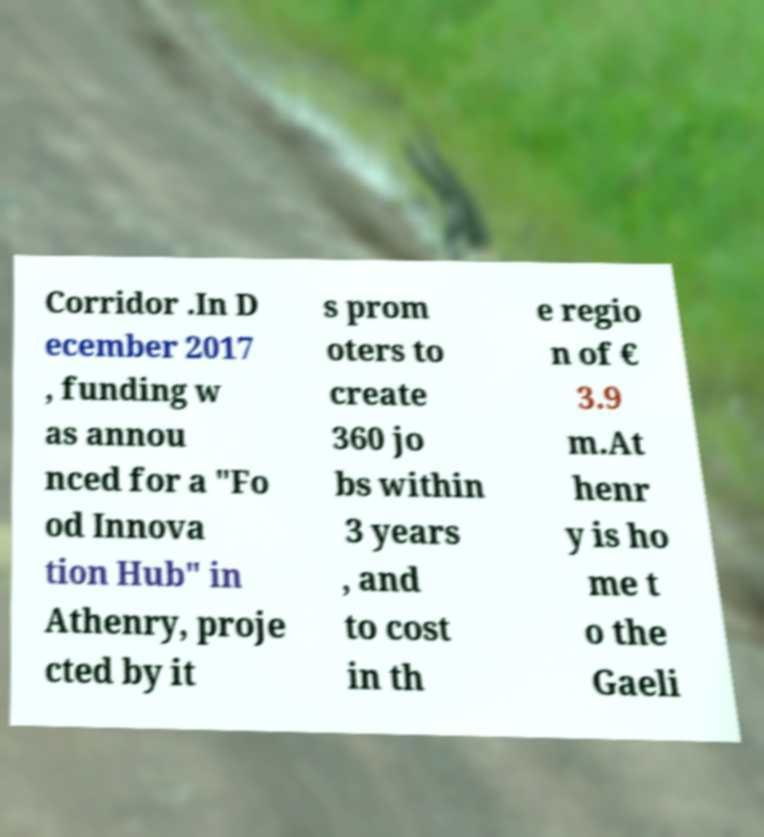For documentation purposes, I need the text within this image transcribed. Could you provide that? Corridor .In D ecember 2017 , funding w as annou nced for a "Fo od Innova tion Hub" in Athenry, proje cted by it s prom oters to create 360 jo bs within 3 years , and to cost in th e regio n of € 3.9 m.At henr y is ho me t o the Gaeli 